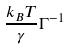<formula> <loc_0><loc_0><loc_500><loc_500>\frac { k _ { B } T } { \gamma } \Gamma ^ { - 1 }</formula> 